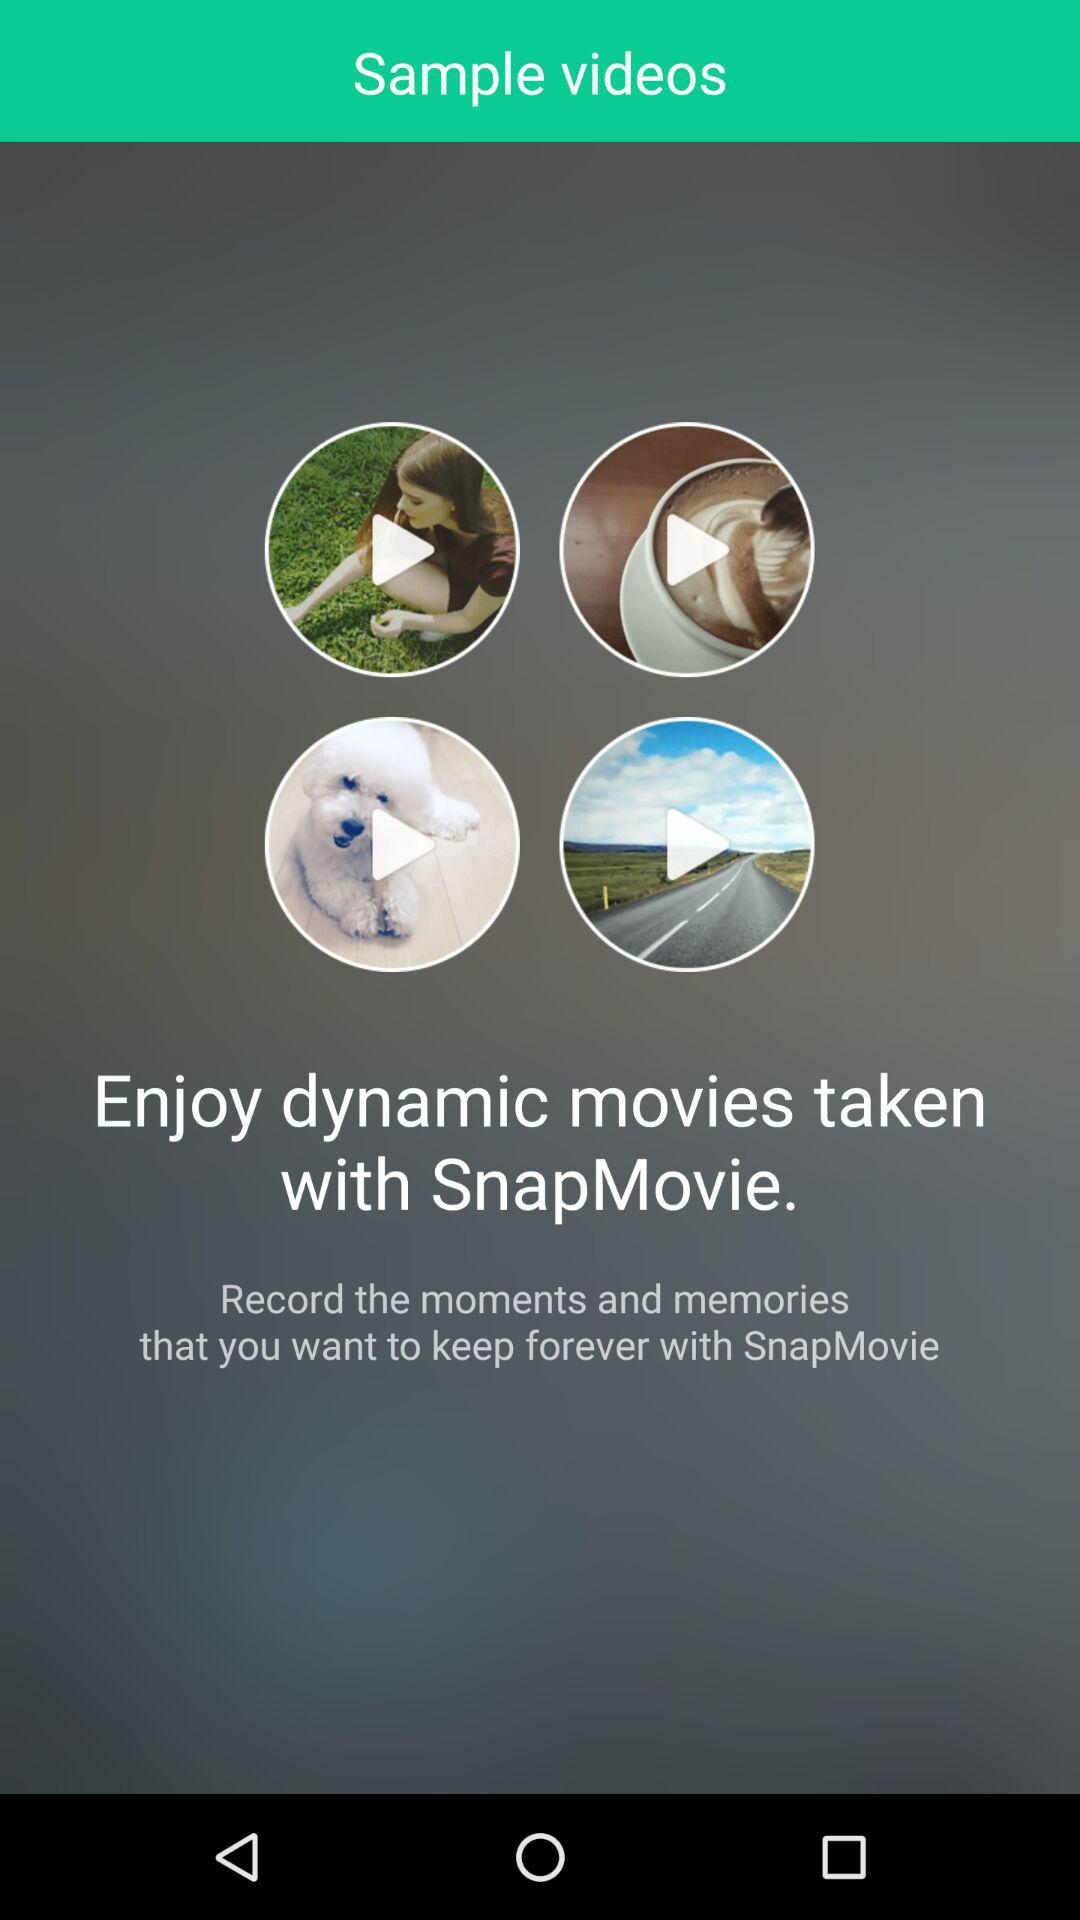What is the name of the application? The name of the application is "SnapMovie". 